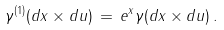Convert formula to latex. <formula><loc_0><loc_0><loc_500><loc_500>\gamma ^ { ( 1 ) } ( d x \times d u ) \, = \, e ^ { x } \gamma ( d x \times d u ) \, .</formula> 